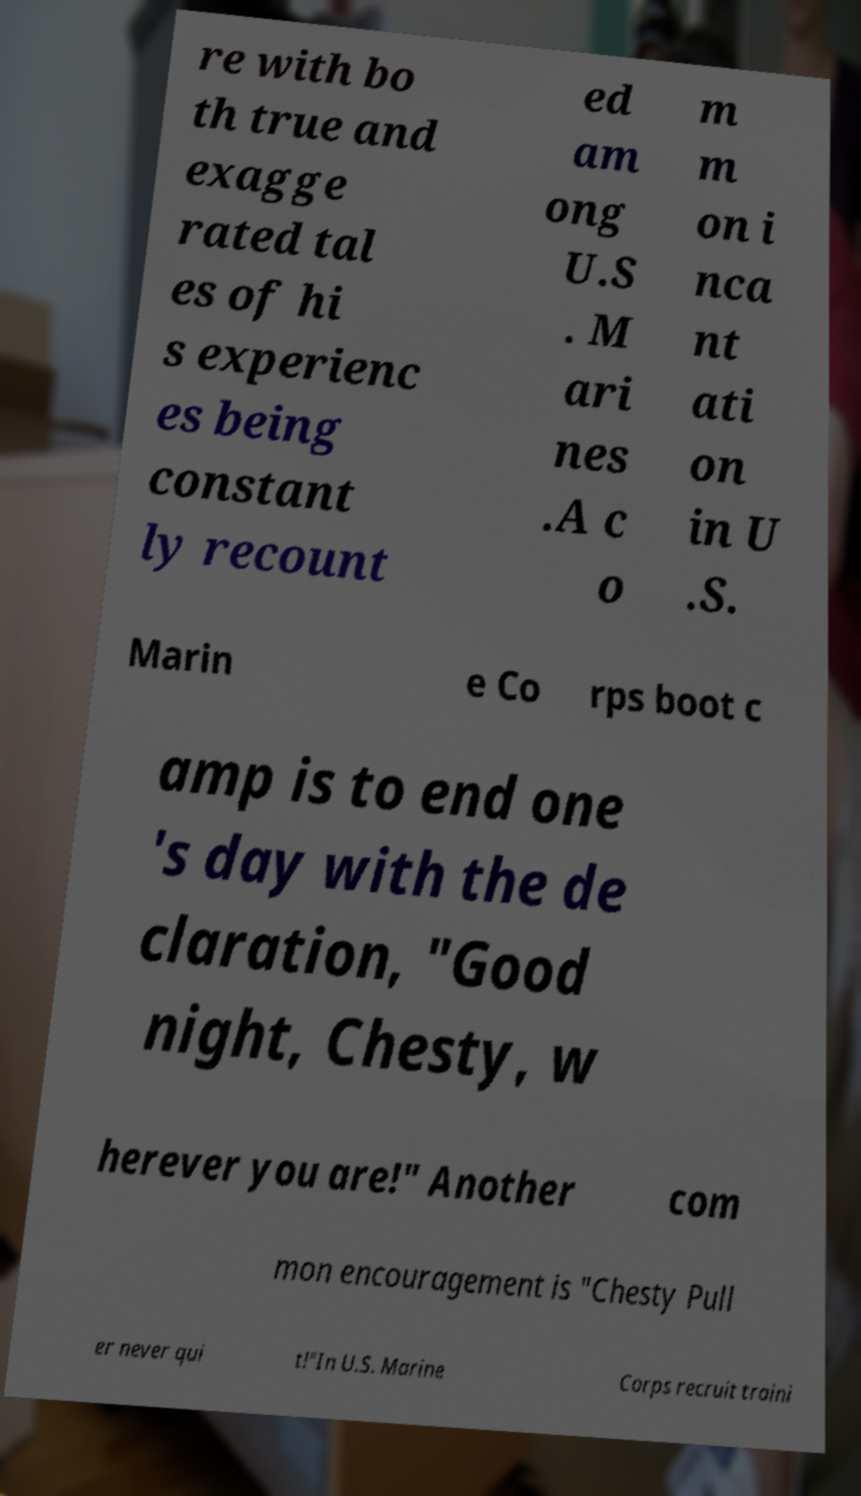Can you accurately transcribe the text from the provided image for me? re with bo th true and exagge rated tal es of hi s experienc es being constant ly recount ed am ong U.S . M ari nes .A c o m m on i nca nt ati on in U .S. Marin e Co rps boot c amp is to end one 's day with the de claration, "Good night, Chesty, w herever you are!" Another com mon encouragement is "Chesty Pull er never qui t!"In U.S. Marine Corps recruit traini 